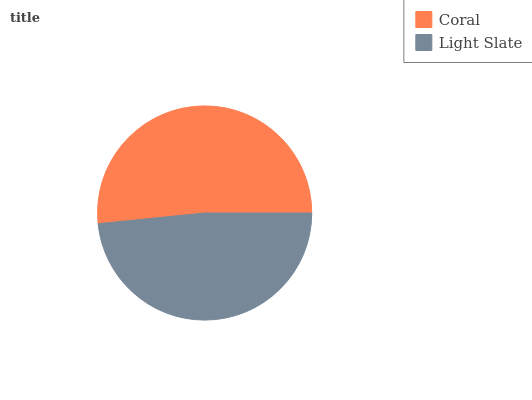Is Light Slate the minimum?
Answer yes or no. Yes. Is Coral the maximum?
Answer yes or no. Yes. Is Light Slate the maximum?
Answer yes or no. No. Is Coral greater than Light Slate?
Answer yes or no. Yes. Is Light Slate less than Coral?
Answer yes or no. Yes. Is Light Slate greater than Coral?
Answer yes or no. No. Is Coral less than Light Slate?
Answer yes or no. No. Is Coral the high median?
Answer yes or no. Yes. Is Light Slate the low median?
Answer yes or no. Yes. Is Light Slate the high median?
Answer yes or no. No. Is Coral the low median?
Answer yes or no. No. 